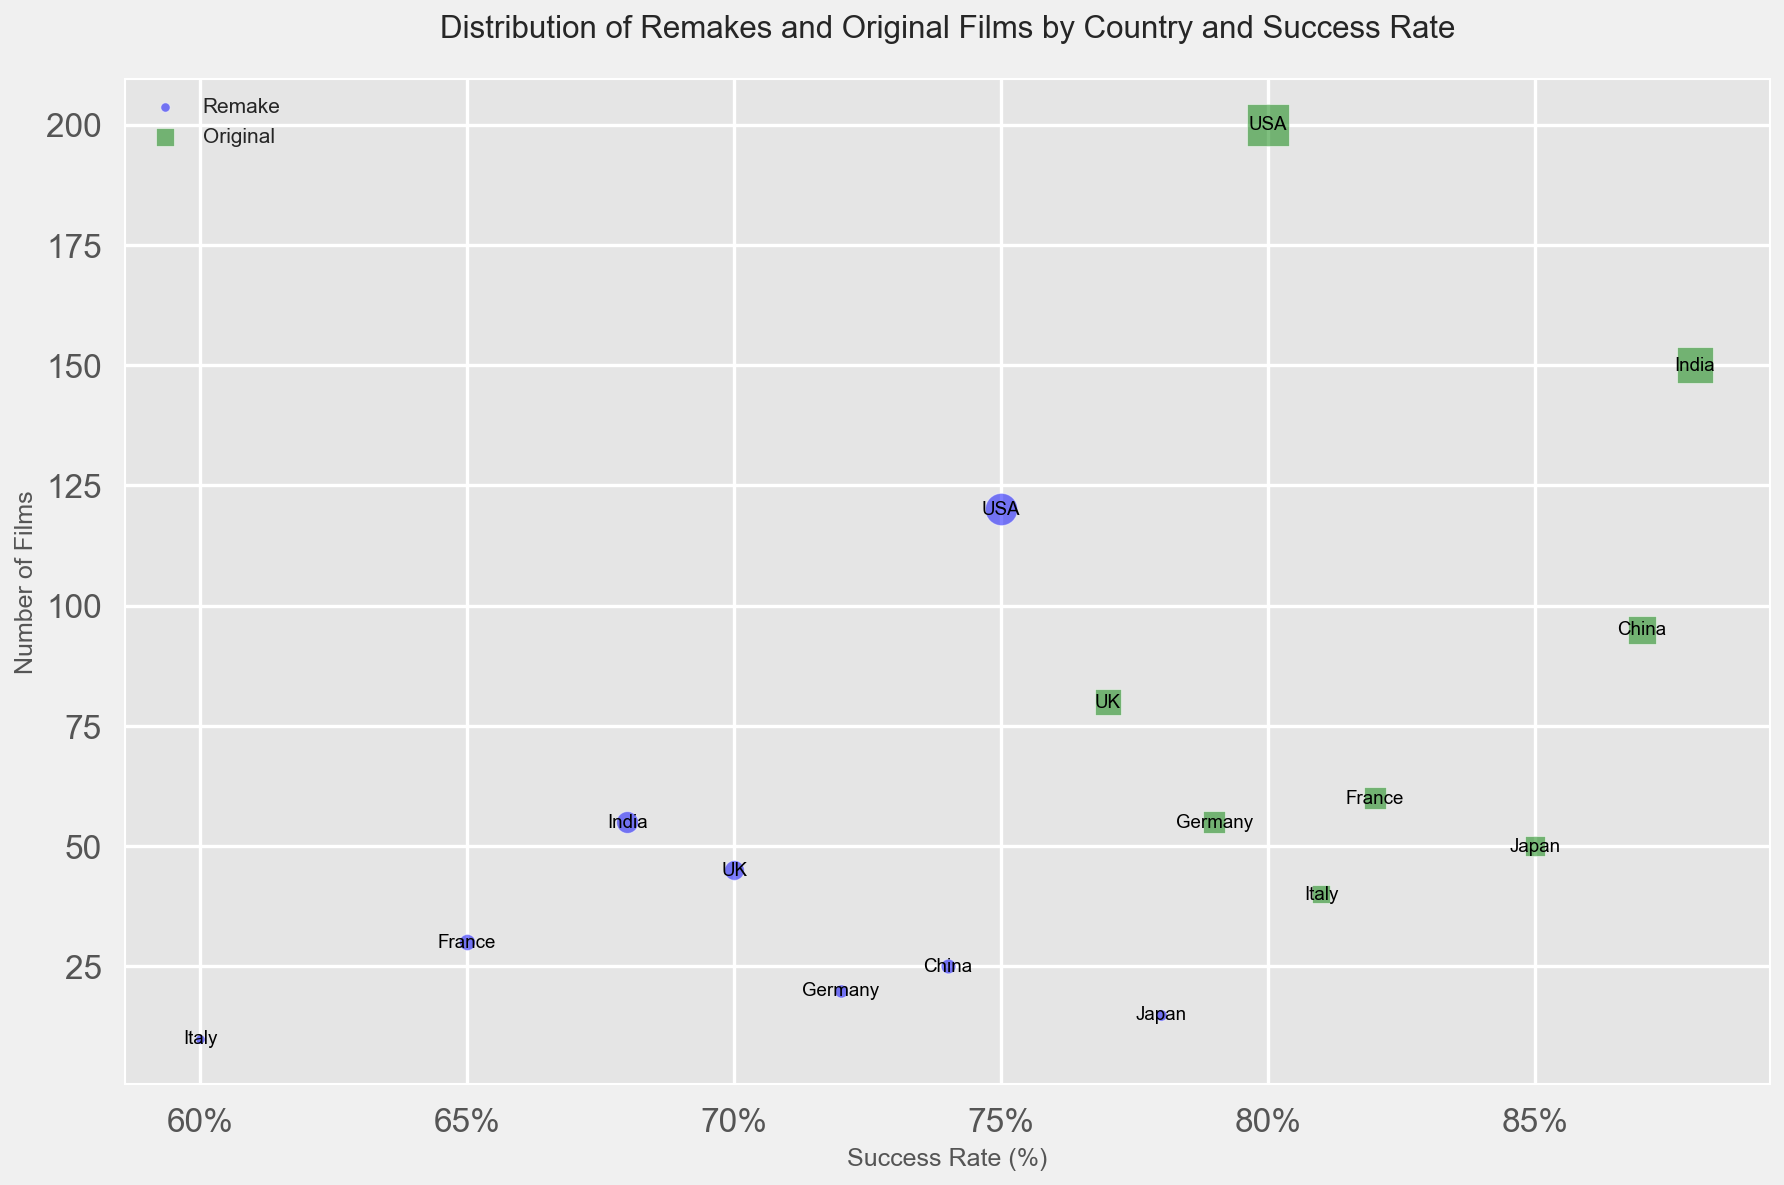Which country has the highest success rate for original films? Identify the bubble for original films (green). Locate the bubble at the highest point on the Success Rate axis. The country with the highest success rate for original films is India with a success rate of 88%.
Answer: India Which country has produced the most remake films? Look for the largest blue bubble (remake films) with the highest value on the Number of Films axis. The USA has produced 120 remake films, which is the highest.
Answer: USA What is the difference in success rate between original and remake films in the UK? Identify the two UK bubbles. The success rate for original films is 77%, and for remakes is 70%. Subtract the success rate of remakes from originals: 77 - 70 = 7.
Answer: 7 Which country has the largest gap in the number of films between remakes and original films? Calculate the difference in the number of films for each country. The USA: 200 - 120 = 80, UK: 80 - 45 = 35, France: 60 - 30 = 30, Japan: 50 - 15 = 35, India: 150 - 55 = 95, Germany: 55 - 20 = 35, China: 95 - 25 = 70, Italy: 40 - 10 = 30. India has the largest difference of 95 films.
Answer: India Comparing Germany and China, which country has a higher success rate for remake films? Find the blue bubbles for Germany and China. Germany's success rate is 72%, while China's success rate is 74%. Thus, China has a higher success rate for remake films.
Answer: China What is the median success rate for the countries' original films? List the success rates of original films: 80 (USA), 77 (UK), 82 (France), 85 (Japan), 88 (India), 79 (Germany), 87 (China), 81 (Italy). Arrange in ascending order: 77, 79, 80, 81, 82, 85, 87, 88. Median of 8 numbers is the average of the 4th and 5th: (81 + 82) / 2 = 81.5.
Answer: 81.5 Which country has the smallest number of both remake and original films combined? Calculate the total number of films for each country: USA: 120+200=320, UK: 45+80=125, France: 30+60=90, Japan: 15+50=65, India: 55+150=205, Germany: 20+55=75, China: 25+95=120, Italy: 10+40=50. Italy has the smallest total with 50 films.
Answer: Italy 